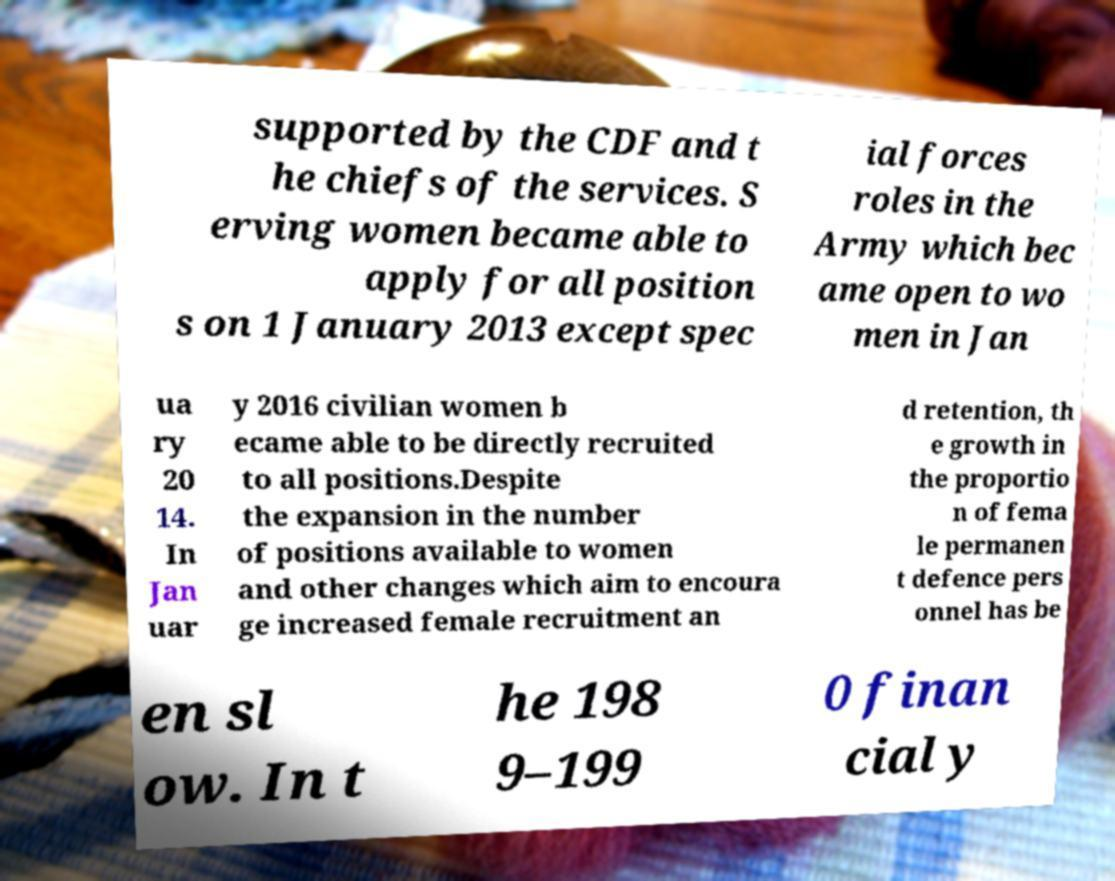Can you accurately transcribe the text from the provided image for me? supported by the CDF and t he chiefs of the services. S erving women became able to apply for all position s on 1 January 2013 except spec ial forces roles in the Army which bec ame open to wo men in Jan ua ry 20 14. In Jan uar y 2016 civilian women b ecame able to be directly recruited to all positions.Despite the expansion in the number of positions available to women and other changes which aim to encoura ge increased female recruitment an d retention, th e growth in the proportio n of fema le permanen t defence pers onnel has be en sl ow. In t he 198 9–199 0 finan cial y 